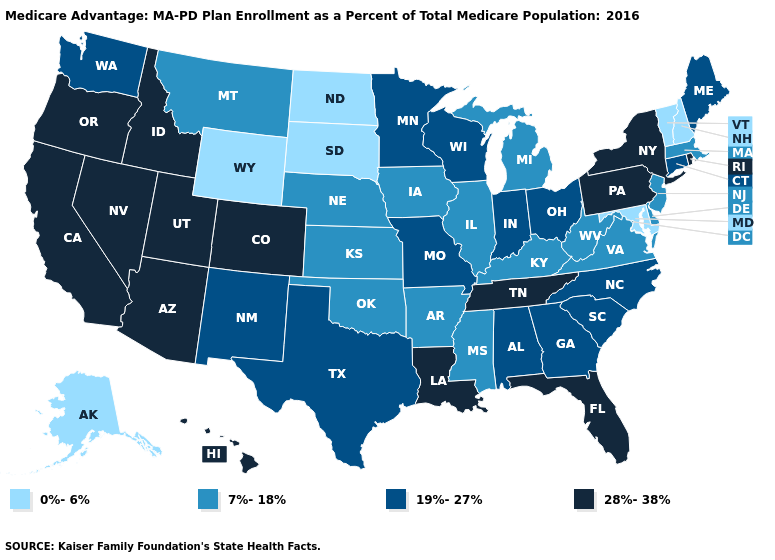What is the highest value in the USA?
Give a very brief answer. 28%-38%. Name the states that have a value in the range 7%-18%?
Be succinct. Arkansas, Delaware, Iowa, Illinois, Kansas, Kentucky, Massachusetts, Michigan, Mississippi, Montana, Nebraska, New Jersey, Oklahoma, Virginia, West Virginia. What is the highest value in the West ?
Keep it brief. 28%-38%. Name the states that have a value in the range 28%-38%?
Answer briefly. Arizona, California, Colorado, Florida, Hawaii, Idaho, Louisiana, Nevada, New York, Oregon, Pennsylvania, Rhode Island, Tennessee, Utah. Name the states that have a value in the range 28%-38%?
Keep it brief. Arizona, California, Colorado, Florida, Hawaii, Idaho, Louisiana, Nevada, New York, Oregon, Pennsylvania, Rhode Island, Tennessee, Utah. Does Idaho have a lower value than Vermont?
Quick response, please. No. Does New York have a higher value than West Virginia?
Be succinct. Yes. What is the value of Kansas?
Quick response, please. 7%-18%. Which states hav the highest value in the South?
Keep it brief. Florida, Louisiana, Tennessee. Which states hav the highest value in the South?
Concise answer only. Florida, Louisiana, Tennessee. What is the value of Alabama?
Quick response, please. 19%-27%. Does Virginia have the lowest value in the South?
Write a very short answer. No. Name the states that have a value in the range 19%-27%?
Quick response, please. Alabama, Connecticut, Georgia, Indiana, Maine, Minnesota, Missouri, North Carolina, New Mexico, Ohio, South Carolina, Texas, Washington, Wisconsin. Name the states that have a value in the range 19%-27%?
Short answer required. Alabama, Connecticut, Georgia, Indiana, Maine, Minnesota, Missouri, North Carolina, New Mexico, Ohio, South Carolina, Texas, Washington, Wisconsin. Which states hav the highest value in the South?
Short answer required. Florida, Louisiana, Tennessee. 